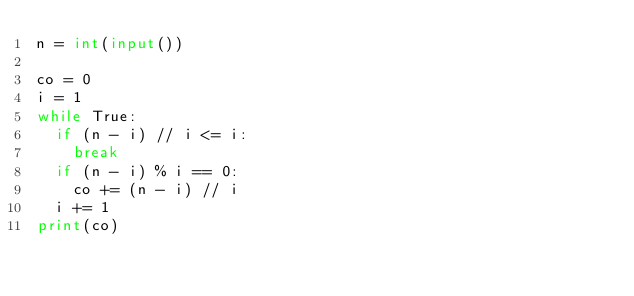<code> <loc_0><loc_0><loc_500><loc_500><_Python_>n = int(input())

co = 0
i = 1
while True:
	if (n - i) // i <= i:
		break
	if (n - i) % i == 0:
		co += (n - i) // i
	i += 1
print(co)</code> 